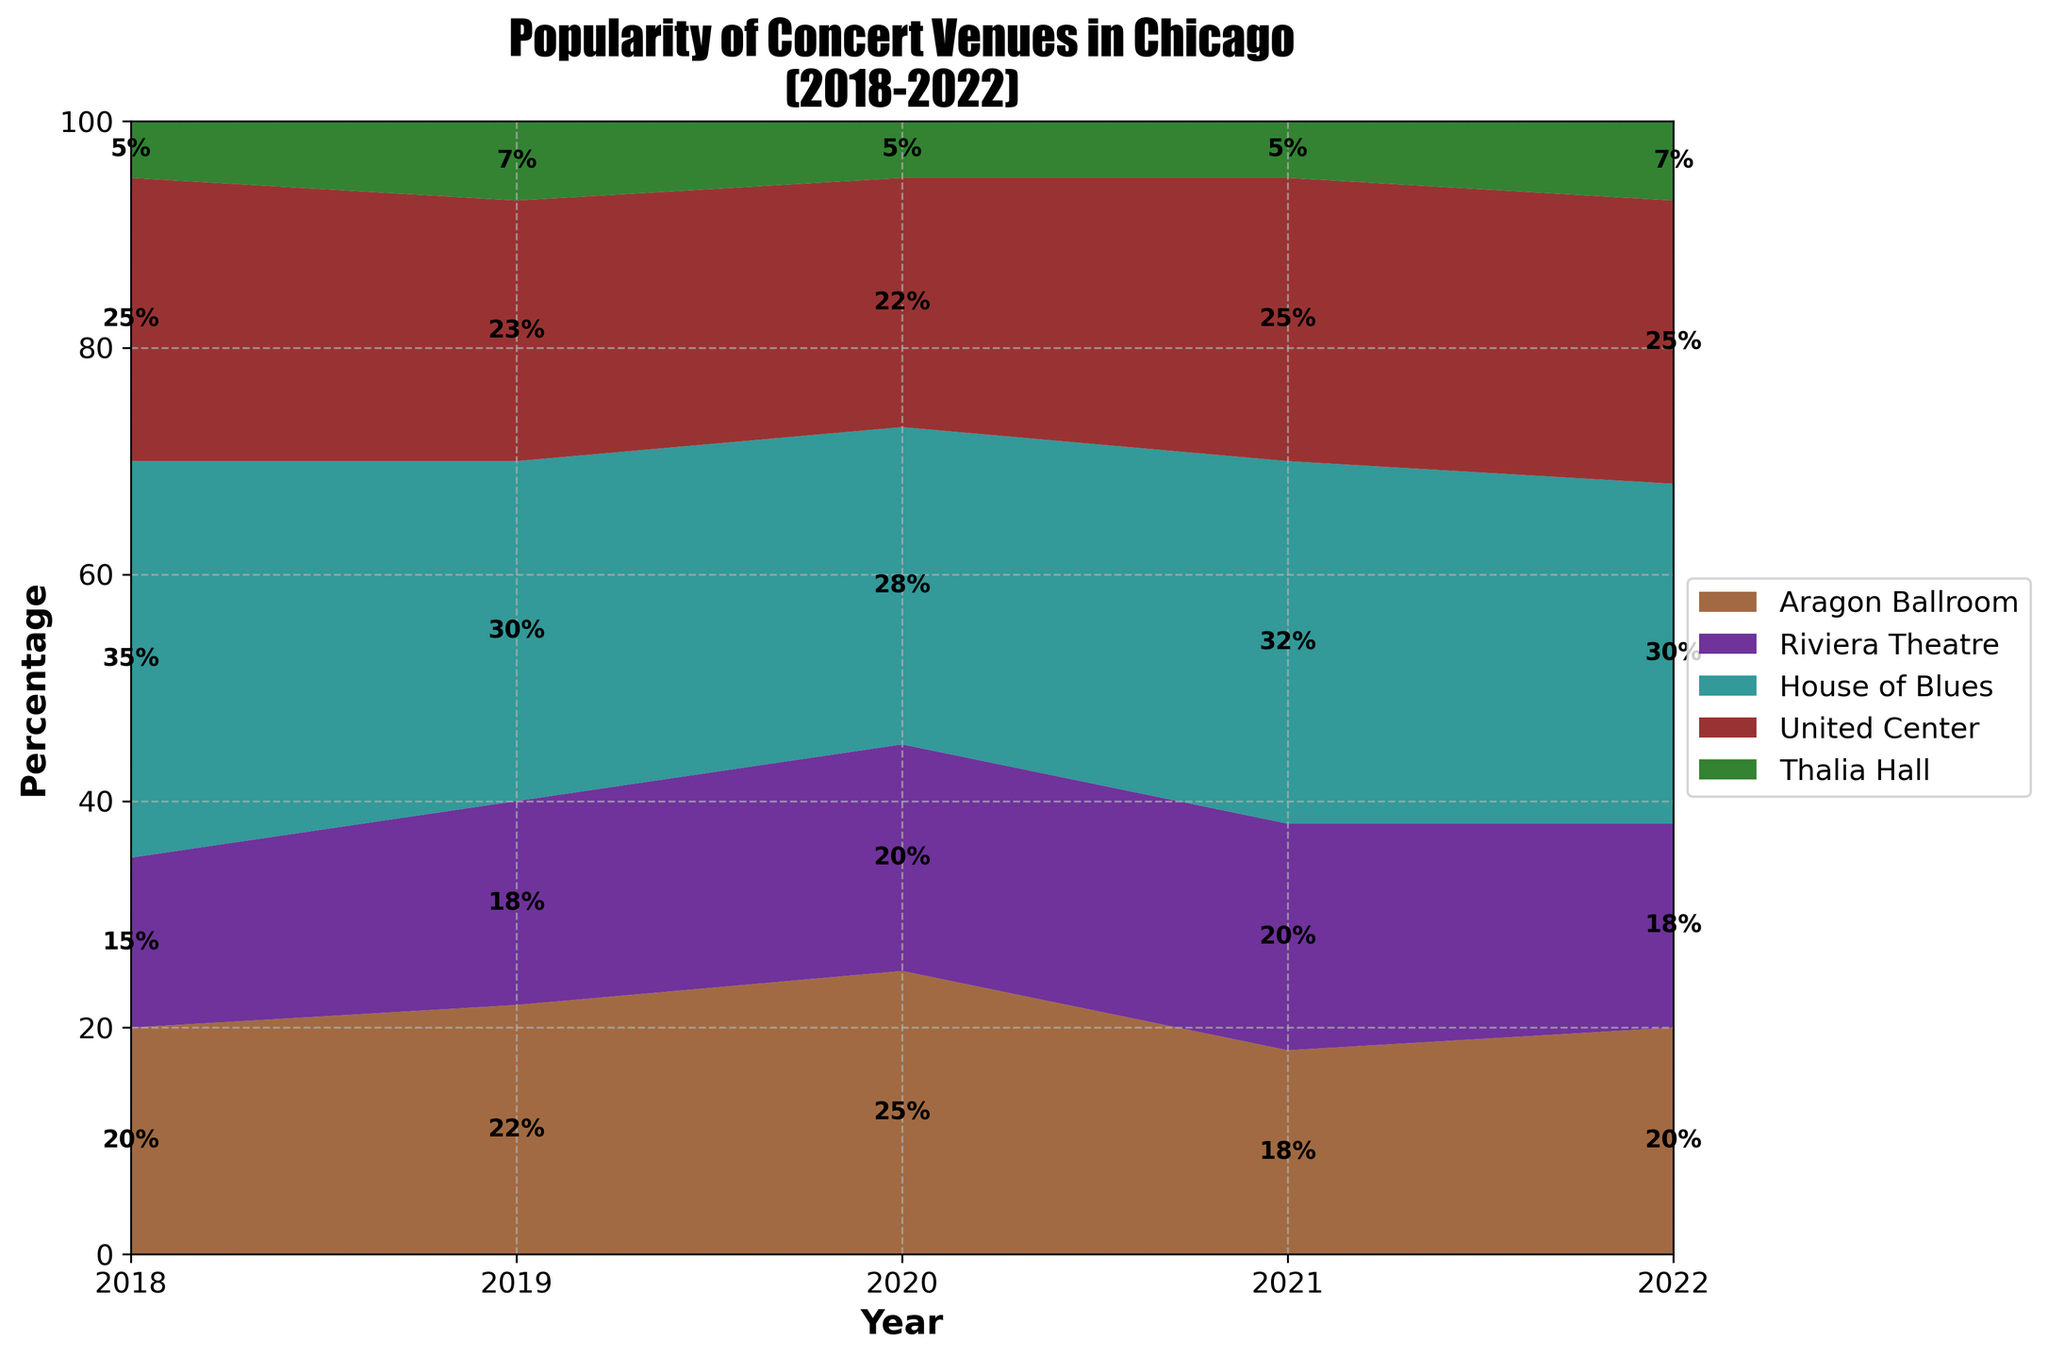What is the title of the chart? The title of the chart is prominently displayed at the top and reads 'Popularity of Concert Venues in Chicago (2018-2022)'.
Answer: Popularity of Concert Venues in Chicago (2018-2022) Which venue type had the highest percentage in 2018? By looking at the 2018 data in the chart, we can see that 'House of Blues' has the largest area, indicating the highest percentage.
Answer: House of Blues What was the percentage of the United Center in 2022? Observing the data for 2022, the area section for 'United Center' is labeled with '25%', indicating its percentage.
Answer: 25% Which venue type showed the most consistent percentage over the five years? By analyzing the areas within the plot, 'Thalia Hall' shows minimal variation in percentage every year, staying roughly around 5% to 7%.
Answer: Thalia Hall How did the popularity of 'Aragon Ballroom' change from 2018 to 2022? 'Aragon Ballroom' starts at 20% in 2018, rises to 22% and 25% in 2019 and 2020 respectively, drops to 18% in 2021, and goes back to 20% in 2022.
Answer: It fluctuated but remained around 20% Between which years did 'Riviera Theatre' have the highest increase in its percentage? Comparing the differences in percentages year by year, the largest increase is from 2018 (15%) to 2019 (18%), which is a 3% increase.
Answer: 2018-2019 In which year was the combined percentage of 'Aragon Ballroom' and 'Riviera Theatre' the highest? Summing the percentages of 'Aragon Ballroom' and 'Riviera Theatre' for each year, 2020 has the highest combined total (25% + 20% = 45%).
Answer: 2020 What is the mean percentage of 'House of Blues' over the five years? Adding the percentages for 'House of Blues' (35%, 30%, 28%, 32%, 30%) and dividing by 5, the calculation is (35 + 30 + 28 + 32 + 30)/5 = 31%.
Answer: 31% Which venue type saw the largest drop in percentage from one year to the next? 'Aragon Ballroom' saw the largest drop, from 25% in 2020 to 18% in 2021, a difference of 7%.
Answer: Aragon Ballroom What total percentage of all venues other than 'House of Blues' was in 2018? Summing the percentages of all venues except 'House of Blues' in 2018: 20% + 15% + 25% + 5% = 65%.
Answer: 65% 